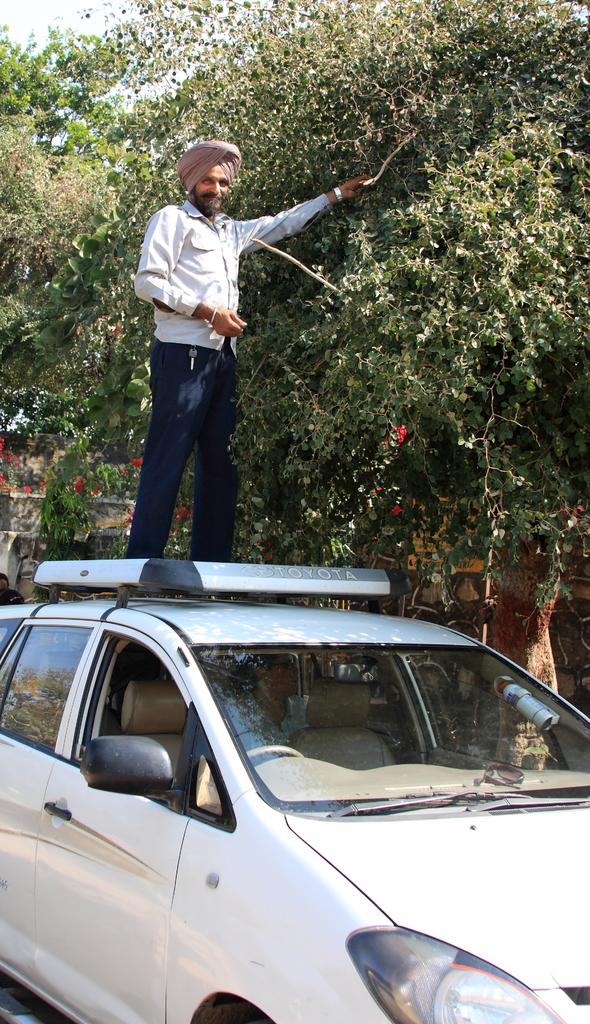What is the man doing in the image? The man is standing on a car. What can be seen in the background of the image? There are trees and the sky visible in the background of the image. What type of wrench is the man using to balance on the car? There is no wrench present in the image, and the man is not using any tools to balance on the car. 